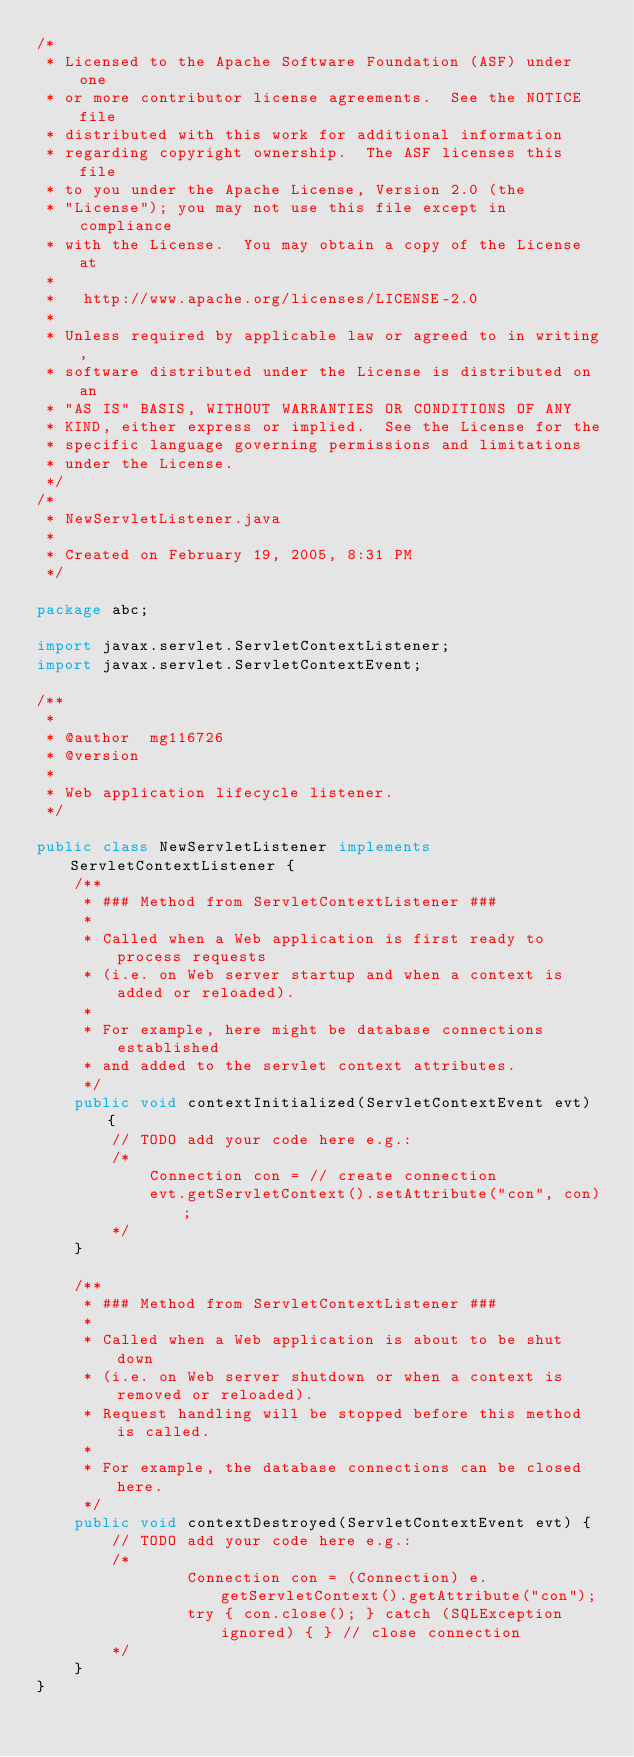<code> <loc_0><loc_0><loc_500><loc_500><_Java_>/*
 * Licensed to the Apache Software Foundation (ASF) under one
 * or more contributor license agreements.  See the NOTICE file
 * distributed with this work for additional information
 * regarding copyright ownership.  The ASF licenses this file
 * to you under the Apache License, Version 2.0 (the
 * "License"); you may not use this file except in compliance
 * with the License.  You may obtain a copy of the License at
 *
 *   http://www.apache.org/licenses/LICENSE-2.0
 *
 * Unless required by applicable law or agreed to in writing,
 * software distributed under the License is distributed on an
 * "AS IS" BASIS, WITHOUT WARRANTIES OR CONDITIONS OF ANY
 * KIND, either express or implied.  See the License for the
 * specific language governing permissions and limitations
 * under the License.
 */
/*
 * NewServletListener.java
 *
 * Created on February 19, 2005, 8:31 PM
 */

package abc;

import javax.servlet.ServletContextListener;
import javax.servlet.ServletContextEvent;

/**
 *
 * @author  mg116726
 * @version
 *
 * Web application lifecycle listener.
 */

public class NewServletListener implements ServletContextListener {
    /**
     * ### Method from ServletContextListener ###
     * 
     * Called when a Web application is first ready to process requests
     * (i.e. on Web server startup and when a context is added or reloaded).
     * 
     * For example, here might be database connections established
     * and added to the servlet context attributes.
     */
    public void contextInitialized(ServletContextEvent evt) {
        // TODO add your code here e.g.:
        /*
            Connection con = // create connection
            evt.getServletContext().setAttribute("con", con);
        */
    }

    /**
     * ### Method from ServletContextListener ###
     * 
     * Called when a Web application is about to be shut down
     * (i.e. on Web server shutdown or when a context is removed or reloaded).
     * Request handling will be stopped before this method is called.
     * 
     * For example, the database connections can be closed here.
     */
    public void contextDestroyed(ServletContextEvent evt) {
        // TODO add your code here e.g.:
        /*
                Connection con = (Connection) e.getServletContext().getAttribute("con");
                try { con.close(); } catch (SQLException ignored) { } // close connection
        */
    }
}
</code> 